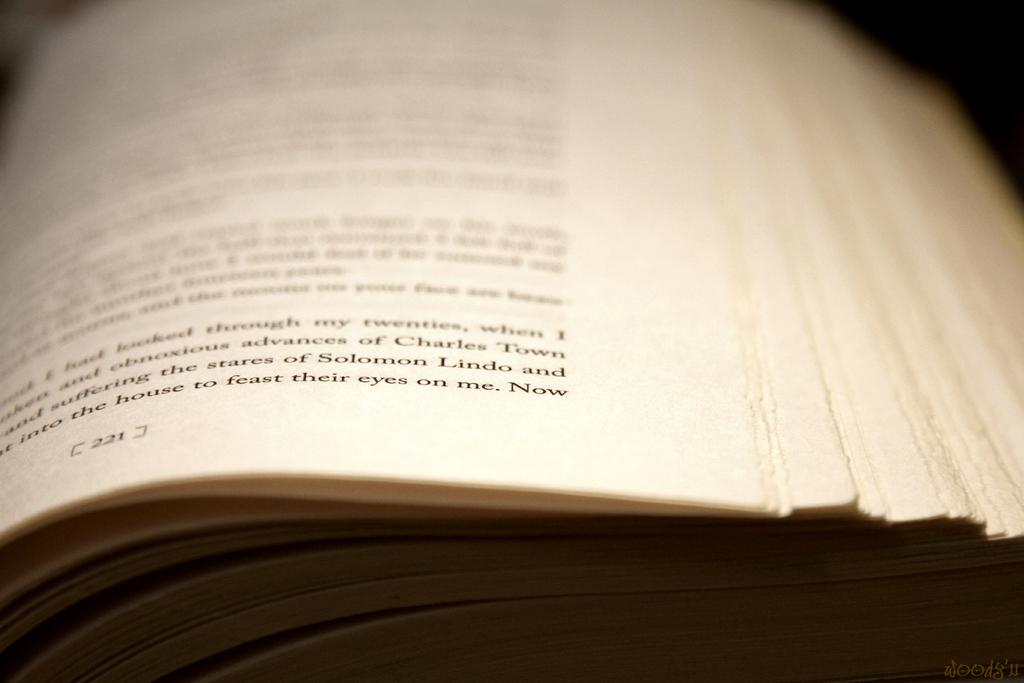<image>
Share a concise interpretation of the image provided. A close up of a book on page 221. 